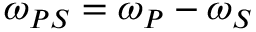Convert formula to latex. <formula><loc_0><loc_0><loc_500><loc_500>\omega _ { P S } = \omega _ { P } - \omega _ { S }</formula> 